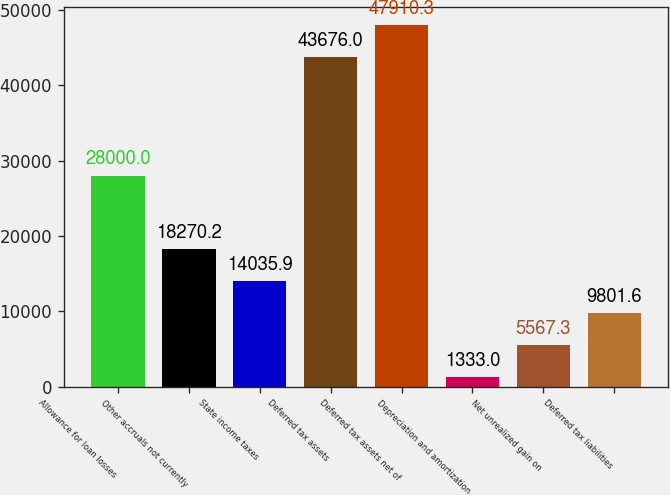Convert chart to OTSL. <chart><loc_0><loc_0><loc_500><loc_500><bar_chart><fcel>Allowance for loan losses<fcel>Other accruals not currently<fcel>State income taxes<fcel>Deferred tax assets<fcel>Deferred tax assets net of<fcel>Depreciation and amortization<fcel>Net unrealized gain on<fcel>Deferred tax liabilities<nl><fcel>28000<fcel>18270.2<fcel>14035.9<fcel>43676<fcel>47910.3<fcel>1333<fcel>5567.3<fcel>9801.6<nl></chart> 